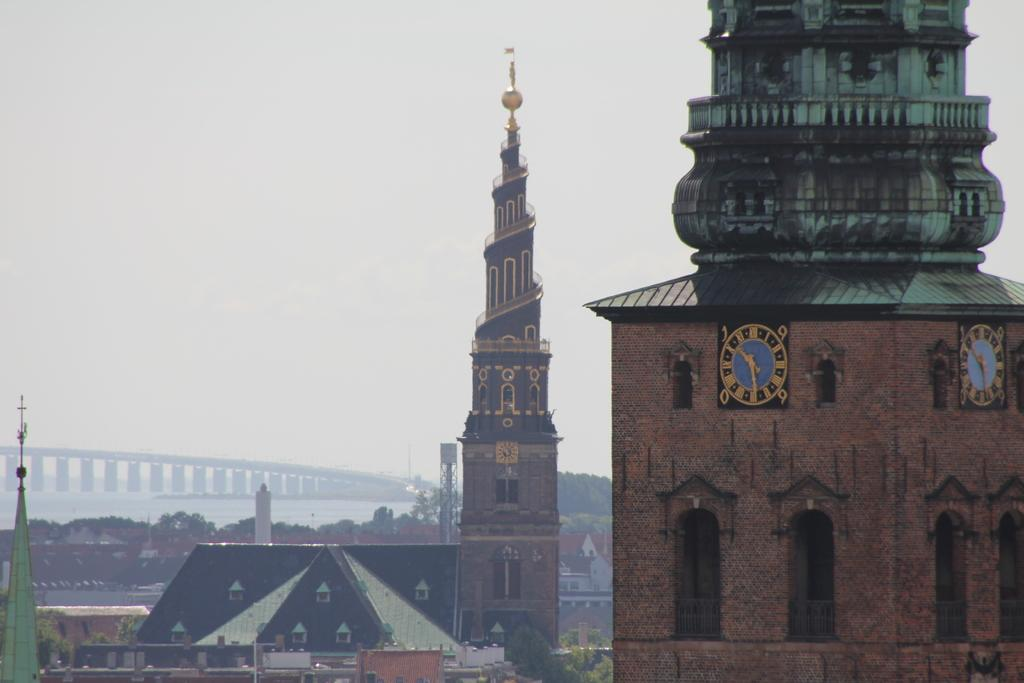What type of structures can be seen in the image? There are buildings in the image. Can you describe any specific features on the buildings? Yes, there is a clock on one of the buildings. What other natural elements are present in the image? There are trees and a river in the image. Is there any man-made structure that crosses the river? Yes, there is a bridge on the river. What type of furniture can be seen in the image? There is no furniture present in the image. What kind of beef is being served at the restaurant in the image? There is no restaurant or beef present in the image. 